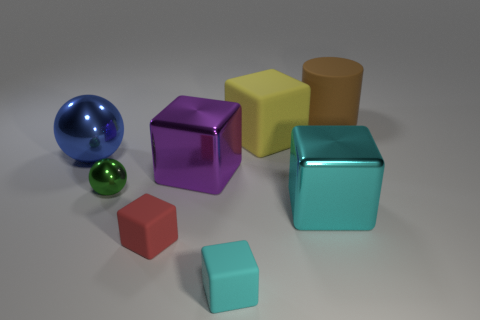Subtract all yellow balls. Subtract all cyan cubes. How many balls are left? 2 Subtract all cubes. How many objects are left? 3 Subtract all red rubber blocks. Subtract all big brown metallic objects. How many objects are left? 7 Add 7 matte cylinders. How many matte cylinders are left? 8 Add 1 big metallic blocks. How many big metallic blocks exist? 3 Subtract 0 gray cubes. How many objects are left? 8 